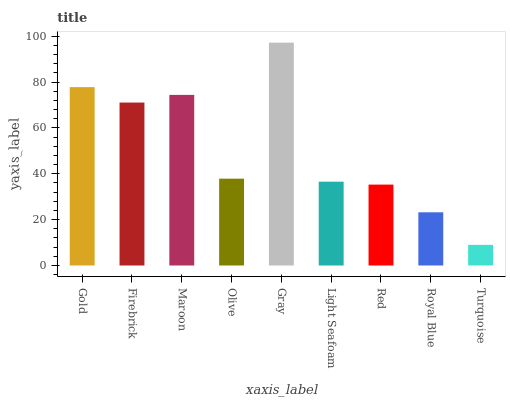Is Turquoise the minimum?
Answer yes or no. Yes. Is Gray the maximum?
Answer yes or no. Yes. Is Firebrick the minimum?
Answer yes or no. No. Is Firebrick the maximum?
Answer yes or no. No. Is Gold greater than Firebrick?
Answer yes or no. Yes. Is Firebrick less than Gold?
Answer yes or no. Yes. Is Firebrick greater than Gold?
Answer yes or no. No. Is Gold less than Firebrick?
Answer yes or no. No. Is Olive the high median?
Answer yes or no. Yes. Is Olive the low median?
Answer yes or no. Yes. Is Firebrick the high median?
Answer yes or no. No. Is Firebrick the low median?
Answer yes or no. No. 